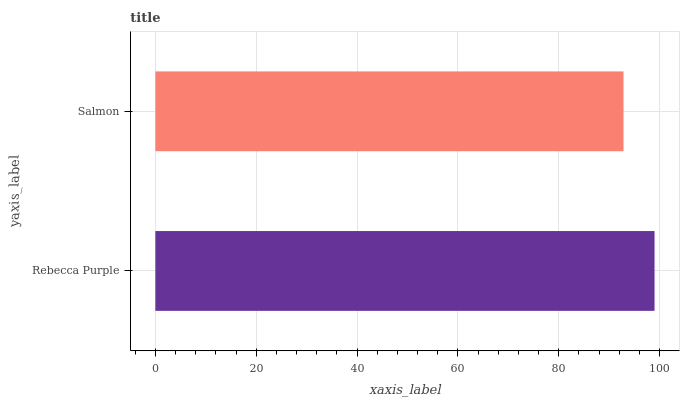Is Salmon the minimum?
Answer yes or no. Yes. Is Rebecca Purple the maximum?
Answer yes or no. Yes. Is Salmon the maximum?
Answer yes or no. No. Is Rebecca Purple greater than Salmon?
Answer yes or no. Yes. Is Salmon less than Rebecca Purple?
Answer yes or no. Yes. Is Salmon greater than Rebecca Purple?
Answer yes or no. No. Is Rebecca Purple less than Salmon?
Answer yes or no. No. Is Rebecca Purple the high median?
Answer yes or no. Yes. Is Salmon the low median?
Answer yes or no. Yes. Is Salmon the high median?
Answer yes or no. No. Is Rebecca Purple the low median?
Answer yes or no. No. 